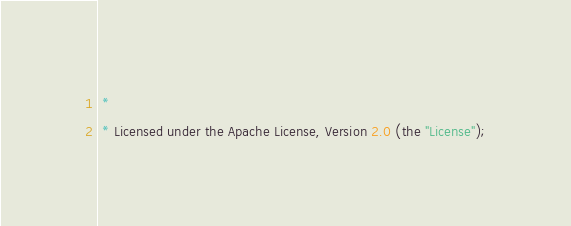Convert code to text. <code><loc_0><loc_0><loc_500><loc_500><_Java_> *
 * Licensed under the Apache License, Version 2.0 (the "License");</code> 